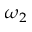<formula> <loc_0><loc_0><loc_500><loc_500>\omega _ { 2 }</formula> 